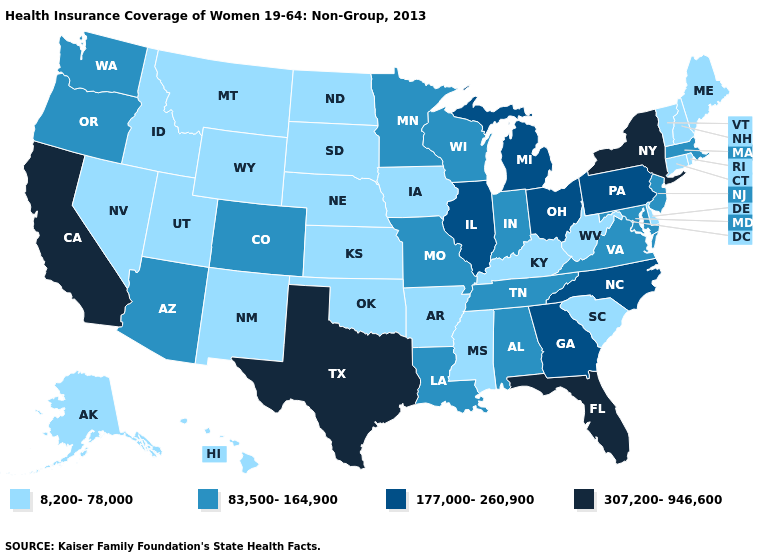Does Minnesota have the highest value in the USA?
Quick response, please. No. What is the lowest value in the Northeast?
Give a very brief answer. 8,200-78,000. Which states have the lowest value in the West?
Concise answer only. Alaska, Hawaii, Idaho, Montana, Nevada, New Mexico, Utah, Wyoming. Does Louisiana have a lower value than Kansas?
Give a very brief answer. No. What is the highest value in the USA?
Keep it brief. 307,200-946,600. What is the value of New Jersey?
Concise answer only. 83,500-164,900. Which states hav the highest value in the MidWest?
Keep it brief. Illinois, Michigan, Ohio. Does Minnesota have a higher value than New Hampshire?
Write a very short answer. Yes. Which states have the lowest value in the USA?
Keep it brief. Alaska, Arkansas, Connecticut, Delaware, Hawaii, Idaho, Iowa, Kansas, Kentucky, Maine, Mississippi, Montana, Nebraska, Nevada, New Hampshire, New Mexico, North Dakota, Oklahoma, Rhode Island, South Carolina, South Dakota, Utah, Vermont, West Virginia, Wyoming. Among the states that border Pennsylvania , does New York have the highest value?
Answer briefly. Yes. Name the states that have a value in the range 307,200-946,600?
Write a very short answer. California, Florida, New York, Texas. What is the value of Florida?
Quick response, please. 307,200-946,600. Does Michigan have the same value as Georgia?
Quick response, please. Yes. Name the states that have a value in the range 177,000-260,900?
Keep it brief. Georgia, Illinois, Michigan, North Carolina, Ohio, Pennsylvania. 